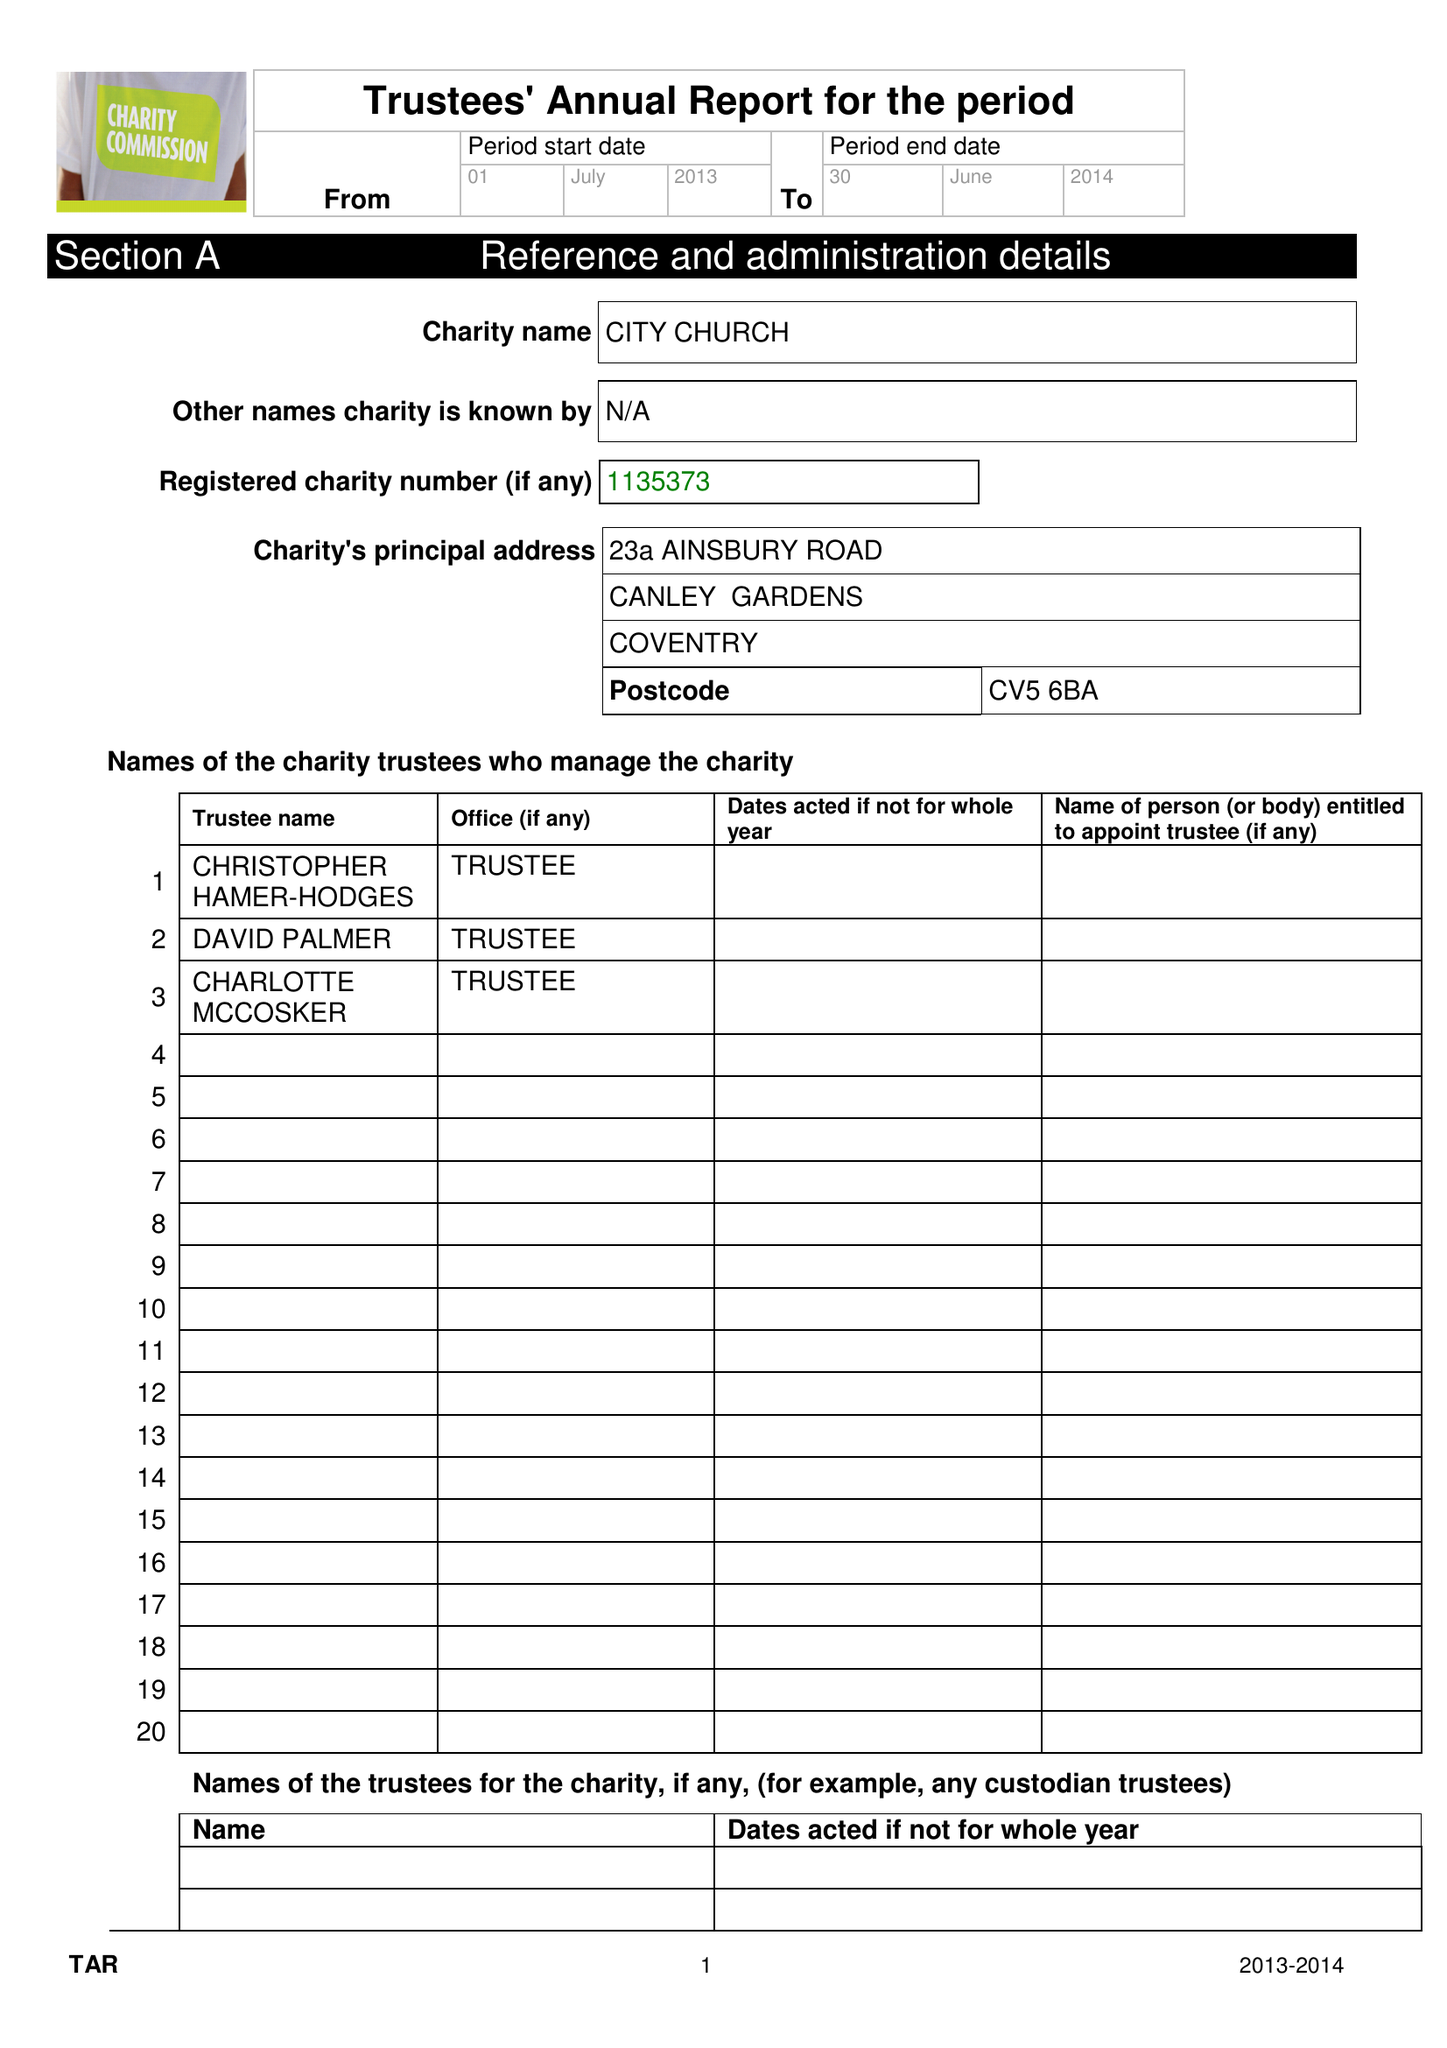What is the value for the income_annually_in_british_pounds?
Answer the question using a single word or phrase. 105721.00 